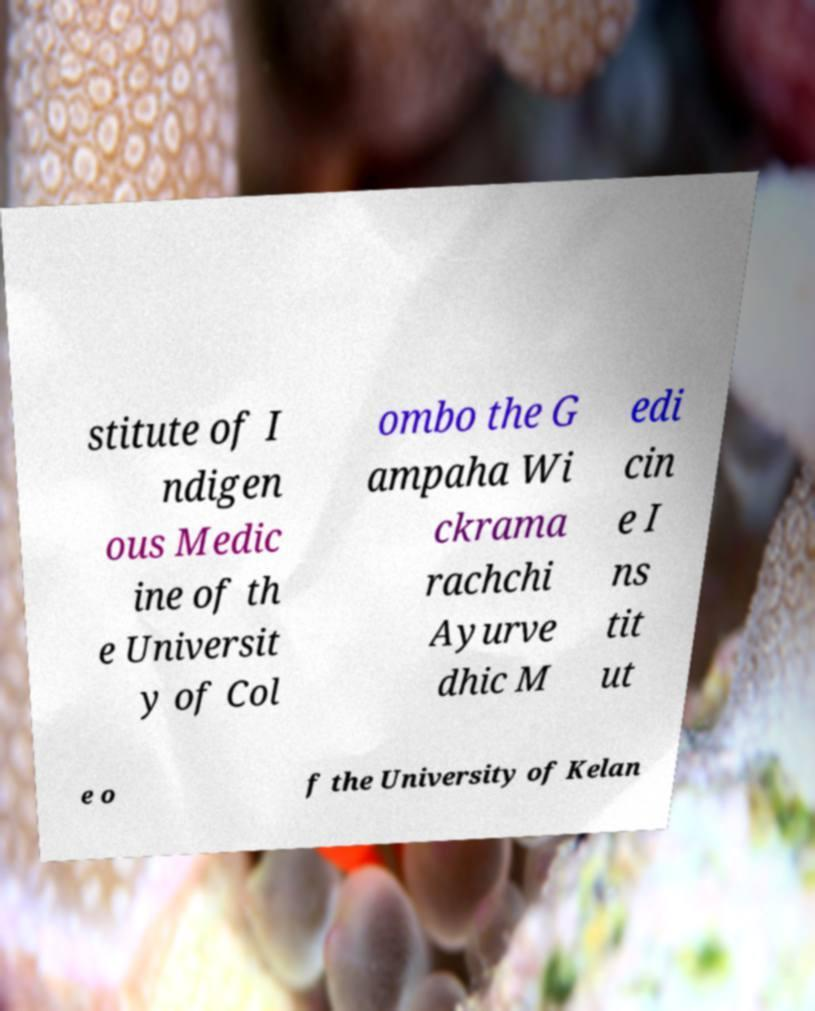There's text embedded in this image that I need extracted. Can you transcribe it verbatim? stitute of I ndigen ous Medic ine of th e Universit y of Col ombo the G ampaha Wi ckrama rachchi Ayurve dhic M edi cin e I ns tit ut e o f the University of Kelan 